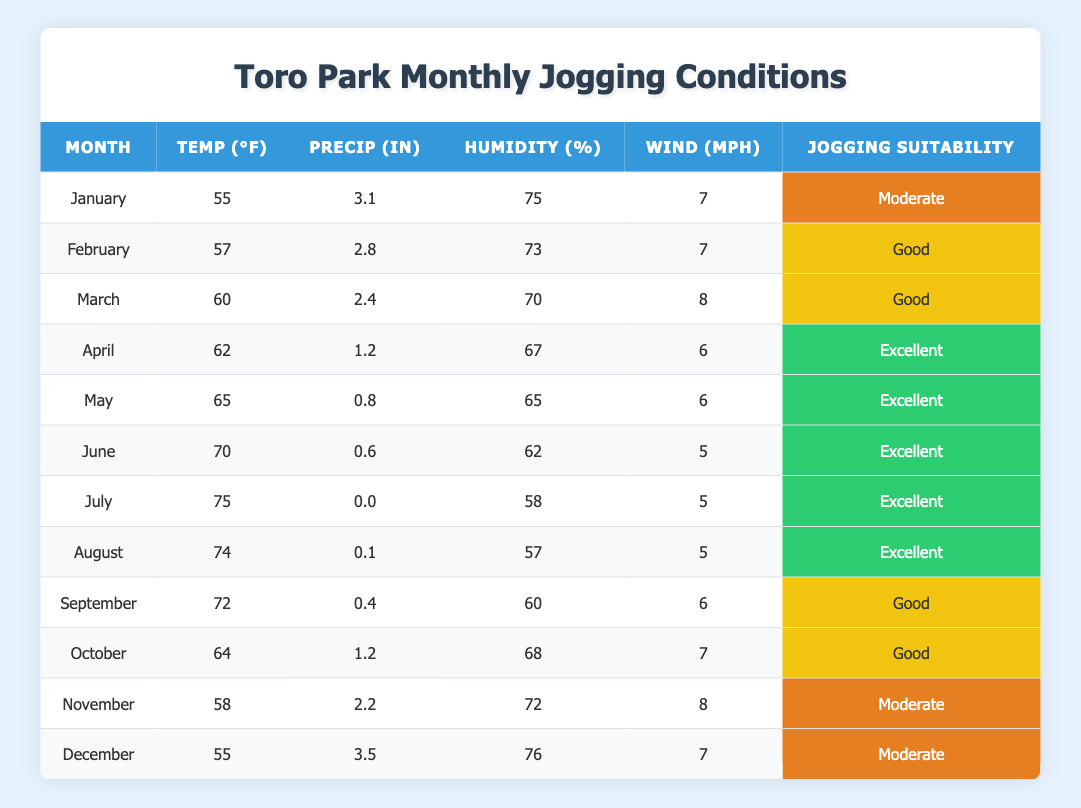What's the jogging suitability in March? In March, the table shows that the jogging suitability is classified as "Good."
Answer: Good What is the average temperature in July? The table lists the average temperature in July as 75°F.
Answer: 75°F How many inches of precipitation does November have? According to the table, November has an average precipitation of 2.2 inches.
Answer: 2.2 inches Which month has the highest humidity percentage? By scanning the table, December has the highest humidity percentage of 76%.
Answer: 76% What is the average temperature for the months of April and May combined? The average for April (62°F) and May (65°F) is calculated as (62 + 65) / 2 = 63.5°F.
Answer: 63.5°F Is the jogging suitability in June classified as excellent? The table shows that June's jogging suitability is indeed classified as "Excellent."
Answer: Yes Which month has the lowest average precipitation? Looking at the data, July has the lowest average precipitation with 0.0 inches.
Answer: 0.0 inches In which month is the combination of temperature, wind speed, and humidity the most favorable for jogging? April, May, June, and July all indicate "Excellent" jogging suitability. However, June with a temperature of 70°F, wind speed of 5 MPH, and humidity of 62% combines favorable conditions among these months.
Answer: June What month has a jogging suitability of moderate? The table indicates that January, November, and December have a jogging suitability classified as "Moderate."
Answer: January, November, December 